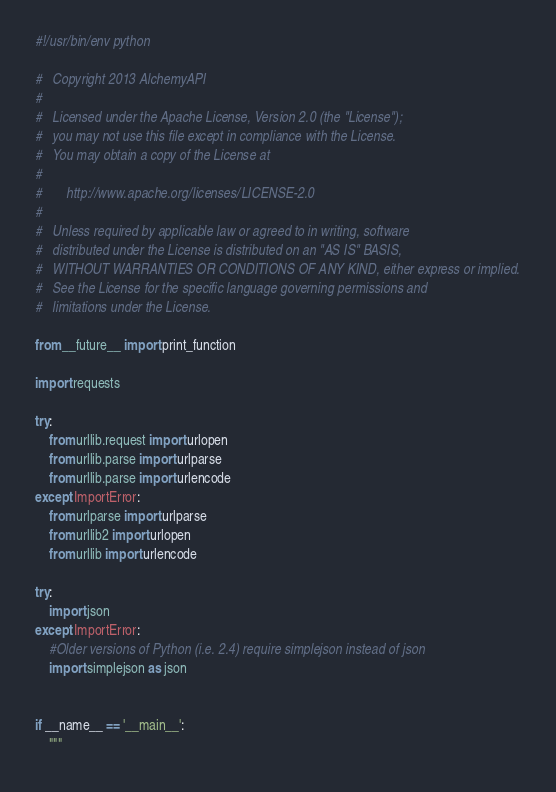Convert code to text. <code><loc_0><loc_0><loc_500><loc_500><_Python_>#!/usr/bin/env python

#	Copyright 2013 AlchemyAPI
#
#   Licensed under the Apache License, Version 2.0 (the "License");
#   you may not use this file except in compliance with the License.
#   You may obtain a copy of the License at
#
#       http://www.apache.org/licenses/LICENSE-2.0
#
#   Unless required by applicable law or agreed to in writing, software
#   distributed under the License is distributed on an "AS IS" BASIS,
#   WITHOUT WARRANTIES OR CONDITIONS OF ANY KIND, either express or implied.
#   See the License for the specific language governing permissions and
#   limitations under the License.

from __future__ import print_function

import requests

try:
	from urllib.request import urlopen
	from urllib.parse import urlparse
	from urllib.parse import urlencode
except ImportError:	
	from urlparse import urlparse
	from urllib2 import urlopen
	from urllib import urlencode

try:
	import json
except ImportError:
	#Older versions of Python (i.e. 2.4) require simplejson instead of json
	import simplejson as json


if __name__ == '__main__':
	"""</code> 